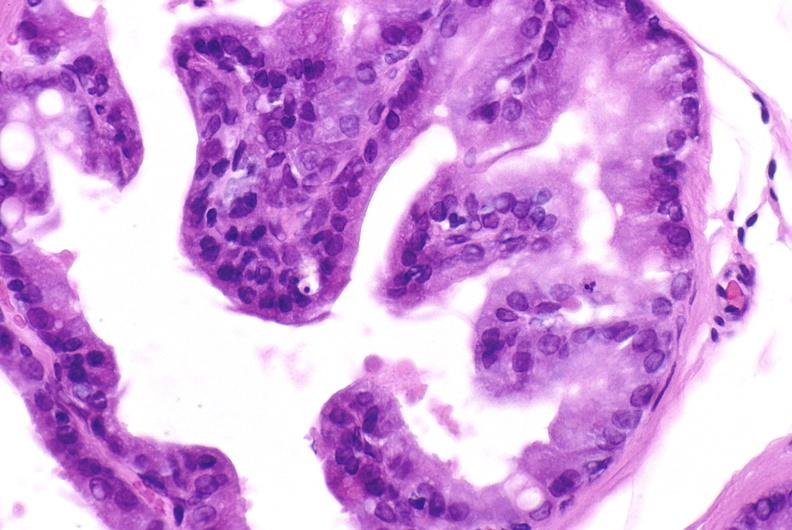what does this image show?
Answer the question using a single word or phrase. Apoptosis in prostate after orchiectomy 